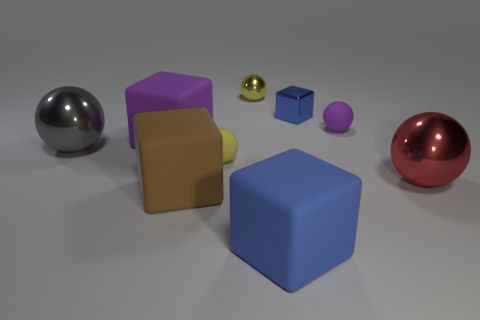What is the shape of the blue thing behind the large metal object that is behind the red ball?
Keep it short and to the point. Cube. There is a big object that is right of the purple thing that is to the right of the yellow object on the right side of the yellow rubber sphere; what shape is it?
Give a very brief answer. Sphere. How many green metallic objects are the same shape as the large blue thing?
Offer a terse response. 0. There is a cube that is in front of the large brown matte object; what number of large brown blocks are right of it?
Give a very brief answer. 0. How many metal things are either tiny blue objects or brown cylinders?
Your answer should be compact. 1. Is there a big brown sphere that has the same material as the large brown object?
Offer a terse response. No. What number of things are either small objects behind the tiny yellow matte thing or big metallic spheres left of the brown rubber block?
Ensure brevity in your answer.  4. There is a large rubber cube that is behind the big red shiny sphere; is it the same color as the tiny shiny block?
Offer a terse response. No. What number of other things are the same color as the small shiny sphere?
Your answer should be very brief. 1. What material is the big blue block?
Your answer should be very brief. Rubber. 